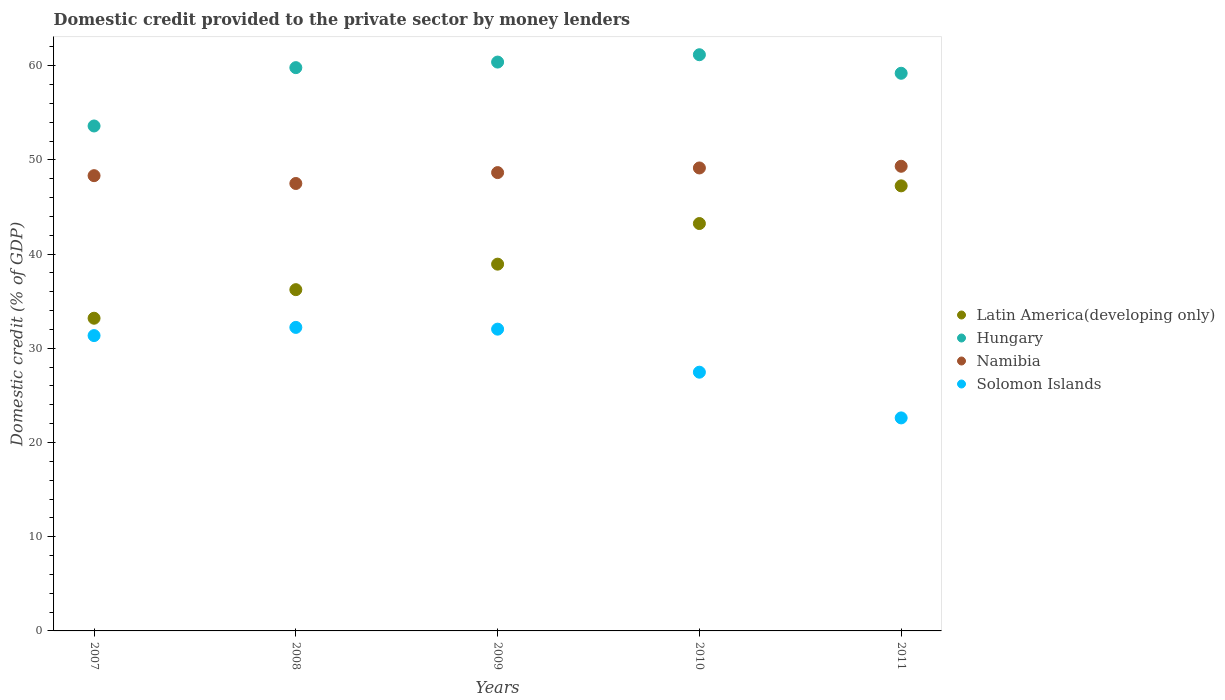How many different coloured dotlines are there?
Give a very brief answer. 4. What is the domestic credit provided to the private sector by money lenders in Solomon Islands in 2010?
Give a very brief answer. 27.46. Across all years, what is the maximum domestic credit provided to the private sector by money lenders in Solomon Islands?
Your response must be concise. 32.22. Across all years, what is the minimum domestic credit provided to the private sector by money lenders in Solomon Islands?
Offer a terse response. 22.61. In which year was the domestic credit provided to the private sector by money lenders in Solomon Islands maximum?
Provide a succinct answer. 2008. What is the total domestic credit provided to the private sector by money lenders in Solomon Islands in the graph?
Make the answer very short. 145.67. What is the difference between the domestic credit provided to the private sector by money lenders in Latin America(developing only) in 2007 and that in 2008?
Provide a short and direct response. -3.03. What is the difference between the domestic credit provided to the private sector by money lenders in Solomon Islands in 2008 and the domestic credit provided to the private sector by money lenders in Hungary in 2007?
Keep it short and to the point. -21.38. What is the average domestic credit provided to the private sector by money lenders in Latin America(developing only) per year?
Provide a short and direct response. 39.77. In the year 2007, what is the difference between the domestic credit provided to the private sector by money lenders in Namibia and domestic credit provided to the private sector by money lenders in Hungary?
Provide a succinct answer. -5.27. In how many years, is the domestic credit provided to the private sector by money lenders in Hungary greater than 18 %?
Your answer should be very brief. 5. What is the ratio of the domestic credit provided to the private sector by money lenders in Hungary in 2009 to that in 2011?
Provide a short and direct response. 1.02. Is the difference between the domestic credit provided to the private sector by money lenders in Namibia in 2007 and 2010 greater than the difference between the domestic credit provided to the private sector by money lenders in Hungary in 2007 and 2010?
Make the answer very short. Yes. What is the difference between the highest and the second highest domestic credit provided to the private sector by money lenders in Hungary?
Your answer should be compact. 0.78. What is the difference between the highest and the lowest domestic credit provided to the private sector by money lenders in Solomon Islands?
Make the answer very short. 9.61. Is the sum of the domestic credit provided to the private sector by money lenders in Namibia in 2007 and 2009 greater than the maximum domestic credit provided to the private sector by money lenders in Solomon Islands across all years?
Your answer should be compact. Yes. Does the domestic credit provided to the private sector by money lenders in Latin America(developing only) monotonically increase over the years?
Provide a succinct answer. Yes. How many dotlines are there?
Keep it short and to the point. 4. What is the difference between two consecutive major ticks on the Y-axis?
Provide a succinct answer. 10. Are the values on the major ticks of Y-axis written in scientific E-notation?
Provide a short and direct response. No. Does the graph contain grids?
Offer a terse response. No. How are the legend labels stacked?
Keep it short and to the point. Vertical. What is the title of the graph?
Make the answer very short. Domestic credit provided to the private sector by money lenders. Does "Central African Republic" appear as one of the legend labels in the graph?
Offer a terse response. No. What is the label or title of the Y-axis?
Your response must be concise. Domestic credit (% of GDP). What is the Domestic credit (% of GDP) in Latin America(developing only) in 2007?
Your answer should be very brief. 33.19. What is the Domestic credit (% of GDP) in Hungary in 2007?
Offer a very short reply. 53.6. What is the Domestic credit (% of GDP) of Namibia in 2007?
Your answer should be compact. 48.32. What is the Domestic credit (% of GDP) in Solomon Islands in 2007?
Give a very brief answer. 31.35. What is the Domestic credit (% of GDP) of Latin America(developing only) in 2008?
Provide a short and direct response. 36.22. What is the Domestic credit (% of GDP) of Hungary in 2008?
Your answer should be compact. 59.79. What is the Domestic credit (% of GDP) in Namibia in 2008?
Offer a terse response. 47.49. What is the Domestic credit (% of GDP) in Solomon Islands in 2008?
Provide a short and direct response. 32.22. What is the Domestic credit (% of GDP) in Latin America(developing only) in 2009?
Offer a terse response. 38.93. What is the Domestic credit (% of GDP) of Hungary in 2009?
Offer a terse response. 60.38. What is the Domestic credit (% of GDP) of Namibia in 2009?
Offer a very short reply. 48.65. What is the Domestic credit (% of GDP) in Solomon Islands in 2009?
Keep it short and to the point. 32.03. What is the Domestic credit (% of GDP) in Latin America(developing only) in 2010?
Ensure brevity in your answer.  43.24. What is the Domestic credit (% of GDP) in Hungary in 2010?
Your answer should be compact. 61.16. What is the Domestic credit (% of GDP) in Namibia in 2010?
Provide a short and direct response. 49.14. What is the Domestic credit (% of GDP) of Solomon Islands in 2010?
Ensure brevity in your answer.  27.46. What is the Domestic credit (% of GDP) of Latin America(developing only) in 2011?
Your answer should be very brief. 47.24. What is the Domestic credit (% of GDP) in Hungary in 2011?
Give a very brief answer. 59.19. What is the Domestic credit (% of GDP) of Namibia in 2011?
Offer a terse response. 49.32. What is the Domestic credit (% of GDP) of Solomon Islands in 2011?
Offer a very short reply. 22.61. Across all years, what is the maximum Domestic credit (% of GDP) in Latin America(developing only)?
Give a very brief answer. 47.24. Across all years, what is the maximum Domestic credit (% of GDP) of Hungary?
Offer a very short reply. 61.16. Across all years, what is the maximum Domestic credit (% of GDP) in Namibia?
Ensure brevity in your answer.  49.32. Across all years, what is the maximum Domestic credit (% of GDP) in Solomon Islands?
Offer a terse response. 32.22. Across all years, what is the minimum Domestic credit (% of GDP) of Latin America(developing only)?
Your answer should be very brief. 33.19. Across all years, what is the minimum Domestic credit (% of GDP) of Hungary?
Your answer should be very brief. 53.6. Across all years, what is the minimum Domestic credit (% of GDP) in Namibia?
Make the answer very short. 47.49. Across all years, what is the minimum Domestic credit (% of GDP) in Solomon Islands?
Provide a short and direct response. 22.61. What is the total Domestic credit (% of GDP) in Latin America(developing only) in the graph?
Ensure brevity in your answer.  198.83. What is the total Domestic credit (% of GDP) of Hungary in the graph?
Your answer should be very brief. 294.12. What is the total Domestic credit (% of GDP) in Namibia in the graph?
Keep it short and to the point. 242.92. What is the total Domestic credit (% of GDP) of Solomon Islands in the graph?
Offer a very short reply. 145.67. What is the difference between the Domestic credit (% of GDP) in Latin America(developing only) in 2007 and that in 2008?
Ensure brevity in your answer.  -3.03. What is the difference between the Domestic credit (% of GDP) of Hungary in 2007 and that in 2008?
Give a very brief answer. -6.19. What is the difference between the Domestic credit (% of GDP) in Namibia in 2007 and that in 2008?
Ensure brevity in your answer.  0.83. What is the difference between the Domestic credit (% of GDP) of Solomon Islands in 2007 and that in 2008?
Your answer should be very brief. -0.87. What is the difference between the Domestic credit (% of GDP) of Latin America(developing only) in 2007 and that in 2009?
Give a very brief answer. -5.74. What is the difference between the Domestic credit (% of GDP) of Hungary in 2007 and that in 2009?
Offer a very short reply. -6.78. What is the difference between the Domestic credit (% of GDP) in Namibia in 2007 and that in 2009?
Ensure brevity in your answer.  -0.33. What is the difference between the Domestic credit (% of GDP) in Solomon Islands in 2007 and that in 2009?
Provide a short and direct response. -0.68. What is the difference between the Domestic credit (% of GDP) of Latin America(developing only) in 2007 and that in 2010?
Your answer should be very brief. -10.05. What is the difference between the Domestic credit (% of GDP) of Hungary in 2007 and that in 2010?
Your response must be concise. -7.56. What is the difference between the Domestic credit (% of GDP) of Namibia in 2007 and that in 2010?
Provide a short and direct response. -0.82. What is the difference between the Domestic credit (% of GDP) in Solomon Islands in 2007 and that in 2010?
Your answer should be very brief. 3.89. What is the difference between the Domestic credit (% of GDP) of Latin America(developing only) in 2007 and that in 2011?
Your answer should be very brief. -14.05. What is the difference between the Domestic credit (% of GDP) in Hungary in 2007 and that in 2011?
Your response must be concise. -5.59. What is the difference between the Domestic credit (% of GDP) in Namibia in 2007 and that in 2011?
Provide a succinct answer. -1. What is the difference between the Domestic credit (% of GDP) of Solomon Islands in 2007 and that in 2011?
Your answer should be very brief. 8.74. What is the difference between the Domestic credit (% of GDP) in Latin America(developing only) in 2008 and that in 2009?
Give a very brief answer. -2.71. What is the difference between the Domestic credit (% of GDP) of Hungary in 2008 and that in 2009?
Provide a short and direct response. -0.59. What is the difference between the Domestic credit (% of GDP) of Namibia in 2008 and that in 2009?
Offer a terse response. -1.16. What is the difference between the Domestic credit (% of GDP) in Solomon Islands in 2008 and that in 2009?
Your response must be concise. 0.19. What is the difference between the Domestic credit (% of GDP) of Latin America(developing only) in 2008 and that in 2010?
Your answer should be very brief. -7.02. What is the difference between the Domestic credit (% of GDP) of Hungary in 2008 and that in 2010?
Your answer should be compact. -1.37. What is the difference between the Domestic credit (% of GDP) of Namibia in 2008 and that in 2010?
Provide a succinct answer. -1.65. What is the difference between the Domestic credit (% of GDP) in Solomon Islands in 2008 and that in 2010?
Make the answer very short. 4.75. What is the difference between the Domestic credit (% of GDP) in Latin America(developing only) in 2008 and that in 2011?
Your response must be concise. -11.02. What is the difference between the Domestic credit (% of GDP) of Hungary in 2008 and that in 2011?
Provide a short and direct response. 0.6. What is the difference between the Domestic credit (% of GDP) of Namibia in 2008 and that in 2011?
Your response must be concise. -1.83. What is the difference between the Domestic credit (% of GDP) of Solomon Islands in 2008 and that in 2011?
Offer a terse response. 9.61. What is the difference between the Domestic credit (% of GDP) of Latin America(developing only) in 2009 and that in 2010?
Offer a terse response. -4.31. What is the difference between the Domestic credit (% of GDP) of Hungary in 2009 and that in 2010?
Provide a succinct answer. -0.78. What is the difference between the Domestic credit (% of GDP) of Namibia in 2009 and that in 2010?
Provide a short and direct response. -0.49. What is the difference between the Domestic credit (% of GDP) of Solomon Islands in 2009 and that in 2010?
Give a very brief answer. 4.57. What is the difference between the Domestic credit (% of GDP) of Latin America(developing only) in 2009 and that in 2011?
Keep it short and to the point. -8.31. What is the difference between the Domestic credit (% of GDP) of Hungary in 2009 and that in 2011?
Offer a terse response. 1.19. What is the difference between the Domestic credit (% of GDP) of Namibia in 2009 and that in 2011?
Offer a terse response. -0.67. What is the difference between the Domestic credit (% of GDP) in Solomon Islands in 2009 and that in 2011?
Your answer should be very brief. 9.42. What is the difference between the Domestic credit (% of GDP) in Latin America(developing only) in 2010 and that in 2011?
Your answer should be very brief. -4. What is the difference between the Domestic credit (% of GDP) of Hungary in 2010 and that in 2011?
Your answer should be very brief. 1.97. What is the difference between the Domestic credit (% of GDP) in Namibia in 2010 and that in 2011?
Your response must be concise. -0.18. What is the difference between the Domestic credit (% of GDP) of Solomon Islands in 2010 and that in 2011?
Make the answer very short. 4.85. What is the difference between the Domestic credit (% of GDP) in Latin America(developing only) in 2007 and the Domestic credit (% of GDP) in Hungary in 2008?
Offer a very short reply. -26.6. What is the difference between the Domestic credit (% of GDP) of Latin America(developing only) in 2007 and the Domestic credit (% of GDP) of Namibia in 2008?
Your answer should be compact. -14.3. What is the difference between the Domestic credit (% of GDP) in Hungary in 2007 and the Domestic credit (% of GDP) in Namibia in 2008?
Make the answer very short. 6.1. What is the difference between the Domestic credit (% of GDP) in Hungary in 2007 and the Domestic credit (% of GDP) in Solomon Islands in 2008?
Make the answer very short. 21.38. What is the difference between the Domestic credit (% of GDP) of Namibia in 2007 and the Domestic credit (% of GDP) of Solomon Islands in 2008?
Give a very brief answer. 16.11. What is the difference between the Domestic credit (% of GDP) of Latin America(developing only) in 2007 and the Domestic credit (% of GDP) of Hungary in 2009?
Give a very brief answer. -27.19. What is the difference between the Domestic credit (% of GDP) of Latin America(developing only) in 2007 and the Domestic credit (% of GDP) of Namibia in 2009?
Your answer should be compact. -15.46. What is the difference between the Domestic credit (% of GDP) in Latin America(developing only) in 2007 and the Domestic credit (% of GDP) in Solomon Islands in 2009?
Give a very brief answer. 1.16. What is the difference between the Domestic credit (% of GDP) in Hungary in 2007 and the Domestic credit (% of GDP) in Namibia in 2009?
Give a very brief answer. 4.95. What is the difference between the Domestic credit (% of GDP) in Hungary in 2007 and the Domestic credit (% of GDP) in Solomon Islands in 2009?
Keep it short and to the point. 21.57. What is the difference between the Domestic credit (% of GDP) of Namibia in 2007 and the Domestic credit (% of GDP) of Solomon Islands in 2009?
Your response must be concise. 16.29. What is the difference between the Domestic credit (% of GDP) of Latin America(developing only) in 2007 and the Domestic credit (% of GDP) of Hungary in 2010?
Make the answer very short. -27.97. What is the difference between the Domestic credit (% of GDP) of Latin America(developing only) in 2007 and the Domestic credit (% of GDP) of Namibia in 2010?
Provide a short and direct response. -15.95. What is the difference between the Domestic credit (% of GDP) in Latin America(developing only) in 2007 and the Domestic credit (% of GDP) in Solomon Islands in 2010?
Offer a very short reply. 5.73. What is the difference between the Domestic credit (% of GDP) in Hungary in 2007 and the Domestic credit (% of GDP) in Namibia in 2010?
Keep it short and to the point. 4.46. What is the difference between the Domestic credit (% of GDP) of Hungary in 2007 and the Domestic credit (% of GDP) of Solomon Islands in 2010?
Ensure brevity in your answer.  26.13. What is the difference between the Domestic credit (% of GDP) in Namibia in 2007 and the Domestic credit (% of GDP) in Solomon Islands in 2010?
Your answer should be compact. 20.86. What is the difference between the Domestic credit (% of GDP) in Latin America(developing only) in 2007 and the Domestic credit (% of GDP) in Hungary in 2011?
Ensure brevity in your answer.  -26. What is the difference between the Domestic credit (% of GDP) of Latin America(developing only) in 2007 and the Domestic credit (% of GDP) of Namibia in 2011?
Provide a short and direct response. -16.13. What is the difference between the Domestic credit (% of GDP) in Latin America(developing only) in 2007 and the Domestic credit (% of GDP) in Solomon Islands in 2011?
Offer a terse response. 10.58. What is the difference between the Domestic credit (% of GDP) of Hungary in 2007 and the Domestic credit (% of GDP) of Namibia in 2011?
Your answer should be very brief. 4.28. What is the difference between the Domestic credit (% of GDP) in Hungary in 2007 and the Domestic credit (% of GDP) in Solomon Islands in 2011?
Give a very brief answer. 30.99. What is the difference between the Domestic credit (% of GDP) of Namibia in 2007 and the Domestic credit (% of GDP) of Solomon Islands in 2011?
Ensure brevity in your answer.  25.71. What is the difference between the Domestic credit (% of GDP) in Latin America(developing only) in 2008 and the Domestic credit (% of GDP) in Hungary in 2009?
Your answer should be very brief. -24.16. What is the difference between the Domestic credit (% of GDP) of Latin America(developing only) in 2008 and the Domestic credit (% of GDP) of Namibia in 2009?
Give a very brief answer. -12.43. What is the difference between the Domestic credit (% of GDP) of Latin America(developing only) in 2008 and the Domestic credit (% of GDP) of Solomon Islands in 2009?
Offer a terse response. 4.19. What is the difference between the Domestic credit (% of GDP) of Hungary in 2008 and the Domestic credit (% of GDP) of Namibia in 2009?
Keep it short and to the point. 11.14. What is the difference between the Domestic credit (% of GDP) in Hungary in 2008 and the Domestic credit (% of GDP) in Solomon Islands in 2009?
Give a very brief answer. 27.76. What is the difference between the Domestic credit (% of GDP) of Namibia in 2008 and the Domestic credit (% of GDP) of Solomon Islands in 2009?
Your response must be concise. 15.46. What is the difference between the Domestic credit (% of GDP) of Latin America(developing only) in 2008 and the Domestic credit (% of GDP) of Hungary in 2010?
Your answer should be very brief. -24.94. What is the difference between the Domestic credit (% of GDP) of Latin America(developing only) in 2008 and the Domestic credit (% of GDP) of Namibia in 2010?
Your answer should be compact. -12.92. What is the difference between the Domestic credit (% of GDP) of Latin America(developing only) in 2008 and the Domestic credit (% of GDP) of Solomon Islands in 2010?
Keep it short and to the point. 8.76. What is the difference between the Domestic credit (% of GDP) in Hungary in 2008 and the Domestic credit (% of GDP) in Namibia in 2010?
Keep it short and to the point. 10.65. What is the difference between the Domestic credit (% of GDP) in Hungary in 2008 and the Domestic credit (% of GDP) in Solomon Islands in 2010?
Your answer should be very brief. 32.33. What is the difference between the Domestic credit (% of GDP) of Namibia in 2008 and the Domestic credit (% of GDP) of Solomon Islands in 2010?
Your response must be concise. 20.03. What is the difference between the Domestic credit (% of GDP) in Latin America(developing only) in 2008 and the Domestic credit (% of GDP) in Hungary in 2011?
Your answer should be compact. -22.97. What is the difference between the Domestic credit (% of GDP) in Latin America(developing only) in 2008 and the Domestic credit (% of GDP) in Namibia in 2011?
Keep it short and to the point. -13.1. What is the difference between the Domestic credit (% of GDP) in Latin America(developing only) in 2008 and the Domestic credit (% of GDP) in Solomon Islands in 2011?
Your response must be concise. 13.61. What is the difference between the Domestic credit (% of GDP) of Hungary in 2008 and the Domestic credit (% of GDP) of Namibia in 2011?
Your answer should be compact. 10.47. What is the difference between the Domestic credit (% of GDP) in Hungary in 2008 and the Domestic credit (% of GDP) in Solomon Islands in 2011?
Ensure brevity in your answer.  37.18. What is the difference between the Domestic credit (% of GDP) in Namibia in 2008 and the Domestic credit (% of GDP) in Solomon Islands in 2011?
Your answer should be very brief. 24.88. What is the difference between the Domestic credit (% of GDP) in Latin America(developing only) in 2009 and the Domestic credit (% of GDP) in Hungary in 2010?
Provide a succinct answer. -22.23. What is the difference between the Domestic credit (% of GDP) of Latin America(developing only) in 2009 and the Domestic credit (% of GDP) of Namibia in 2010?
Ensure brevity in your answer.  -10.21. What is the difference between the Domestic credit (% of GDP) of Latin America(developing only) in 2009 and the Domestic credit (% of GDP) of Solomon Islands in 2010?
Offer a terse response. 11.47. What is the difference between the Domestic credit (% of GDP) of Hungary in 2009 and the Domestic credit (% of GDP) of Namibia in 2010?
Make the answer very short. 11.24. What is the difference between the Domestic credit (% of GDP) in Hungary in 2009 and the Domestic credit (% of GDP) in Solomon Islands in 2010?
Your response must be concise. 32.92. What is the difference between the Domestic credit (% of GDP) in Namibia in 2009 and the Domestic credit (% of GDP) in Solomon Islands in 2010?
Your answer should be compact. 21.19. What is the difference between the Domestic credit (% of GDP) in Latin America(developing only) in 2009 and the Domestic credit (% of GDP) in Hungary in 2011?
Your answer should be compact. -20.26. What is the difference between the Domestic credit (% of GDP) of Latin America(developing only) in 2009 and the Domestic credit (% of GDP) of Namibia in 2011?
Offer a very short reply. -10.39. What is the difference between the Domestic credit (% of GDP) in Latin America(developing only) in 2009 and the Domestic credit (% of GDP) in Solomon Islands in 2011?
Provide a short and direct response. 16.32. What is the difference between the Domestic credit (% of GDP) of Hungary in 2009 and the Domestic credit (% of GDP) of Namibia in 2011?
Give a very brief answer. 11.06. What is the difference between the Domestic credit (% of GDP) of Hungary in 2009 and the Domestic credit (% of GDP) of Solomon Islands in 2011?
Keep it short and to the point. 37.77. What is the difference between the Domestic credit (% of GDP) in Namibia in 2009 and the Domestic credit (% of GDP) in Solomon Islands in 2011?
Provide a succinct answer. 26.04. What is the difference between the Domestic credit (% of GDP) in Latin America(developing only) in 2010 and the Domestic credit (% of GDP) in Hungary in 2011?
Give a very brief answer. -15.95. What is the difference between the Domestic credit (% of GDP) in Latin America(developing only) in 2010 and the Domestic credit (% of GDP) in Namibia in 2011?
Make the answer very short. -6.08. What is the difference between the Domestic credit (% of GDP) in Latin America(developing only) in 2010 and the Domestic credit (% of GDP) in Solomon Islands in 2011?
Provide a succinct answer. 20.63. What is the difference between the Domestic credit (% of GDP) of Hungary in 2010 and the Domestic credit (% of GDP) of Namibia in 2011?
Offer a very short reply. 11.84. What is the difference between the Domestic credit (% of GDP) in Hungary in 2010 and the Domestic credit (% of GDP) in Solomon Islands in 2011?
Make the answer very short. 38.55. What is the difference between the Domestic credit (% of GDP) of Namibia in 2010 and the Domestic credit (% of GDP) of Solomon Islands in 2011?
Your response must be concise. 26.53. What is the average Domestic credit (% of GDP) of Latin America(developing only) per year?
Your response must be concise. 39.77. What is the average Domestic credit (% of GDP) of Hungary per year?
Keep it short and to the point. 58.82. What is the average Domestic credit (% of GDP) of Namibia per year?
Ensure brevity in your answer.  48.58. What is the average Domestic credit (% of GDP) in Solomon Islands per year?
Give a very brief answer. 29.13. In the year 2007, what is the difference between the Domestic credit (% of GDP) of Latin America(developing only) and Domestic credit (% of GDP) of Hungary?
Keep it short and to the point. -20.41. In the year 2007, what is the difference between the Domestic credit (% of GDP) of Latin America(developing only) and Domestic credit (% of GDP) of Namibia?
Provide a short and direct response. -15.13. In the year 2007, what is the difference between the Domestic credit (% of GDP) of Latin America(developing only) and Domestic credit (% of GDP) of Solomon Islands?
Make the answer very short. 1.84. In the year 2007, what is the difference between the Domestic credit (% of GDP) in Hungary and Domestic credit (% of GDP) in Namibia?
Give a very brief answer. 5.27. In the year 2007, what is the difference between the Domestic credit (% of GDP) in Hungary and Domestic credit (% of GDP) in Solomon Islands?
Make the answer very short. 22.25. In the year 2007, what is the difference between the Domestic credit (% of GDP) in Namibia and Domestic credit (% of GDP) in Solomon Islands?
Provide a succinct answer. 16.97. In the year 2008, what is the difference between the Domestic credit (% of GDP) of Latin America(developing only) and Domestic credit (% of GDP) of Hungary?
Offer a terse response. -23.57. In the year 2008, what is the difference between the Domestic credit (% of GDP) in Latin America(developing only) and Domestic credit (% of GDP) in Namibia?
Offer a very short reply. -11.27. In the year 2008, what is the difference between the Domestic credit (% of GDP) of Latin America(developing only) and Domestic credit (% of GDP) of Solomon Islands?
Make the answer very short. 4.01. In the year 2008, what is the difference between the Domestic credit (% of GDP) in Hungary and Domestic credit (% of GDP) in Namibia?
Your response must be concise. 12.3. In the year 2008, what is the difference between the Domestic credit (% of GDP) in Hungary and Domestic credit (% of GDP) in Solomon Islands?
Offer a terse response. 27.57. In the year 2008, what is the difference between the Domestic credit (% of GDP) of Namibia and Domestic credit (% of GDP) of Solomon Islands?
Make the answer very short. 15.28. In the year 2009, what is the difference between the Domestic credit (% of GDP) in Latin America(developing only) and Domestic credit (% of GDP) in Hungary?
Provide a succinct answer. -21.45. In the year 2009, what is the difference between the Domestic credit (% of GDP) in Latin America(developing only) and Domestic credit (% of GDP) in Namibia?
Provide a succinct answer. -9.72. In the year 2009, what is the difference between the Domestic credit (% of GDP) of Latin America(developing only) and Domestic credit (% of GDP) of Solomon Islands?
Keep it short and to the point. 6.9. In the year 2009, what is the difference between the Domestic credit (% of GDP) in Hungary and Domestic credit (% of GDP) in Namibia?
Your answer should be very brief. 11.73. In the year 2009, what is the difference between the Domestic credit (% of GDP) of Hungary and Domestic credit (% of GDP) of Solomon Islands?
Your answer should be compact. 28.35. In the year 2009, what is the difference between the Domestic credit (% of GDP) of Namibia and Domestic credit (% of GDP) of Solomon Islands?
Offer a very short reply. 16.62. In the year 2010, what is the difference between the Domestic credit (% of GDP) in Latin America(developing only) and Domestic credit (% of GDP) in Hungary?
Keep it short and to the point. -17.92. In the year 2010, what is the difference between the Domestic credit (% of GDP) in Latin America(developing only) and Domestic credit (% of GDP) in Namibia?
Keep it short and to the point. -5.9. In the year 2010, what is the difference between the Domestic credit (% of GDP) in Latin America(developing only) and Domestic credit (% of GDP) in Solomon Islands?
Your answer should be compact. 15.78. In the year 2010, what is the difference between the Domestic credit (% of GDP) of Hungary and Domestic credit (% of GDP) of Namibia?
Keep it short and to the point. 12.02. In the year 2010, what is the difference between the Domestic credit (% of GDP) in Hungary and Domestic credit (% of GDP) in Solomon Islands?
Your answer should be very brief. 33.7. In the year 2010, what is the difference between the Domestic credit (% of GDP) in Namibia and Domestic credit (% of GDP) in Solomon Islands?
Offer a very short reply. 21.68. In the year 2011, what is the difference between the Domestic credit (% of GDP) in Latin America(developing only) and Domestic credit (% of GDP) in Hungary?
Ensure brevity in your answer.  -11.95. In the year 2011, what is the difference between the Domestic credit (% of GDP) in Latin America(developing only) and Domestic credit (% of GDP) in Namibia?
Give a very brief answer. -2.08. In the year 2011, what is the difference between the Domestic credit (% of GDP) of Latin America(developing only) and Domestic credit (% of GDP) of Solomon Islands?
Your answer should be compact. 24.63. In the year 2011, what is the difference between the Domestic credit (% of GDP) in Hungary and Domestic credit (% of GDP) in Namibia?
Provide a succinct answer. 9.87. In the year 2011, what is the difference between the Domestic credit (% of GDP) in Hungary and Domestic credit (% of GDP) in Solomon Islands?
Offer a very short reply. 36.58. In the year 2011, what is the difference between the Domestic credit (% of GDP) in Namibia and Domestic credit (% of GDP) in Solomon Islands?
Give a very brief answer. 26.71. What is the ratio of the Domestic credit (% of GDP) of Latin America(developing only) in 2007 to that in 2008?
Provide a succinct answer. 0.92. What is the ratio of the Domestic credit (% of GDP) in Hungary in 2007 to that in 2008?
Keep it short and to the point. 0.9. What is the ratio of the Domestic credit (% of GDP) in Namibia in 2007 to that in 2008?
Keep it short and to the point. 1.02. What is the ratio of the Domestic credit (% of GDP) in Latin America(developing only) in 2007 to that in 2009?
Your response must be concise. 0.85. What is the ratio of the Domestic credit (% of GDP) of Hungary in 2007 to that in 2009?
Provide a succinct answer. 0.89. What is the ratio of the Domestic credit (% of GDP) of Namibia in 2007 to that in 2009?
Give a very brief answer. 0.99. What is the ratio of the Domestic credit (% of GDP) of Solomon Islands in 2007 to that in 2009?
Give a very brief answer. 0.98. What is the ratio of the Domestic credit (% of GDP) of Latin America(developing only) in 2007 to that in 2010?
Give a very brief answer. 0.77. What is the ratio of the Domestic credit (% of GDP) in Hungary in 2007 to that in 2010?
Give a very brief answer. 0.88. What is the ratio of the Domestic credit (% of GDP) of Namibia in 2007 to that in 2010?
Provide a succinct answer. 0.98. What is the ratio of the Domestic credit (% of GDP) in Solomon Islands in 2007 to that in 2010?
Keep it short and to the point. 1.14. What is the ratio of the Domestic credit (% of GDP) of Latin America(developing only) in 2007 to that in 2011?
Offer a very short reply. 0.7. What is the ratio of the Domestic credit (% of GDP) in Hungary in 2007 to that in 2011?
Offer a terse response. 0.91. What is the ratio of the Domestic credit (% of GDP) of Namibia in 2007 to that in 2011?
Your answer should be very brief. 0.98. What is the ratio of the Domestic credit (% of GDP) in Solomon Islands in 2007 to that in 2011?
Offer a terse response. 1.39. What is the ratio of the Domestic credit (% of GDP) in Latin America(developing only) in 2008 to that in 2009?
Give a very brief answer. 0.93. What is the ratio of the Domestic credit (% of GDP) of Hungary in 2008 to that in 2009?
Your answer should be compact. 0.99. What is the ratio of the Domestic credit (% of GDP) in Namibia in 2008 to that in 2009?
Ensure brevity in your answer.  0.98. What is the ratio of the Domestic credit (% of GDP) of Solomon Islands in 2008 to that in 2009?
Offer a terse response. 1.01. What is the ratio of the Domestic credit (% of GDP) in Latin America(developing only) in 2008 to that in 2010?
Your answer should be compact. 0.84. What is the ratio of the Domestic credit (% of GDP) of Hungary in 2008 to that in 2010?
Make the answer very short. 0.98. What is the ratio of the Domestic credit (% of GDP) in Namibia in 2008 to that in 2010?
Make the answer very short. 0.97. What is the ratio of the Domestic credit (% of GDP) in Solomon Islands in 2008 to that in 2010?
Give a very brief answer. 1.17. What is the ratio of the Domestic credit (% of GDP) of Latin America(developing only) in 2008 to that in 2011?
Give a very brief answer. 0.77. What is the ratio of the Domestic credit (% of GDP) in Namibia in 2008 to that in 2011?
Your answer should be very brief. 0.96. What is the ratio of the Domestic credit (% of GDP) of Solomon Islands in 2008 to that in 2011?
Your answer should be very brief. 1.42. What is the ratio of the Domestic credit (% of GDP) in Latin America(developing only) in 2009 to that in 2010?
Keep it short and to the point. 0.9. What is the ratio of the Domestic credit (% of GDP) in Hungary in 2009 to that in 2010?
Offer a very short reply. 0.99. What is the ratio of the Domestic credit (% of GDP) in Solomon Islands in 2009 to that in 2010?
Your answer should be very brief. 1.17. What is the ratio of the Domestic credit (% of GDP) in Latin America(developing only) in 2009 to that in 2011?
Your answer should be very brief. 0.82. What is the ratio of the Domestic credit (% of GDP) in Hungary in 2009 to that in 2011?
Offer a very short reply. 1.02. What is the ratio of the Domestic credit (% of GDP) of Namibia in 2009 to that in 2011?
Make the answer very short. 0.99. What is the ratio of the Domestic credit (% of GDP) in Solomon Islands in 2009 to that in 2011?
Your response must be concise. 1.42. What is the ratio of the Domestic credit (% of GDP) in Latin America(developing only) in 2010 to that in 2011?
Offer a very short reply. 0.92. What is the ratio of the Domestic credit (% of GDP) in Hungary in 2010 to that in 2011?
Give a very brief answer. 1.03. What is the ratio of the Domestic credit (% of GDP) of Solomon Islands in 2010 to that in 2011?
Ensure brevity in your answer.  1.21. What is the difference between the highest and the second highest Domestic credit (% of GDP) of Latin America(developing only)?
Your answer should be compact. 4. What is the difference between the highest and the second highest Domestic credit (% of GDP) in Hungary?
Offer a very short reply. 0.78. What is the difference between the highest and the second highest Domestic credit (% of GDP) of Namibia?
Provide a short and direct response. 0.18. What is the difference between the highest and the second highest Domestic credit (% of GDP) of Solomon Islands?
Your answer should be very brief. 0.19. What is the difference between the highest and the lowest Domestic credit (% of GDP) of Latin America(developing only)?
Make the answer very short. 14.05. What is the difference between the highest and the lowest Domestic credit (% of GDP) of Hungary?
Offer a very short reply. 7.56. What is the difference between the highest and the lowest Domestic credit (% of GDP) in Namibia?
Your answer should be very brief. 1.83. What is the difference between the highest and the lowest Domestic credit (% of GDP) in Solomon Islands?
Provide a succinct answer. 9.61. 